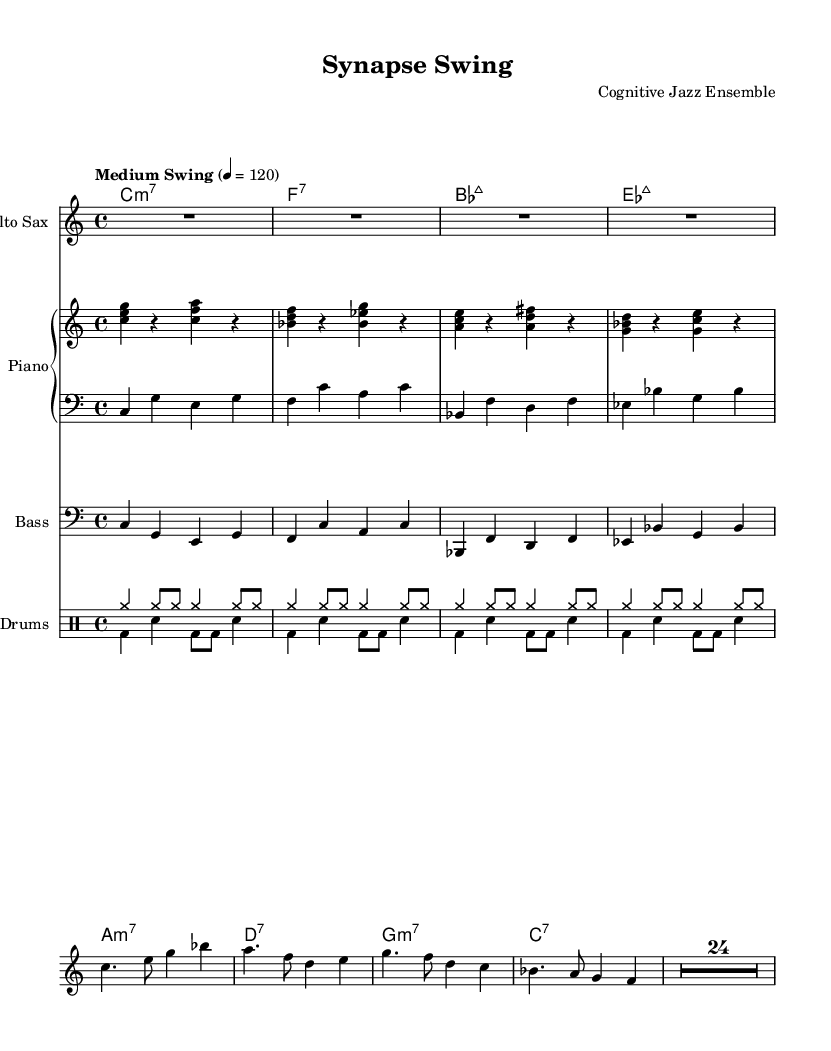What is the key signature of this music? The key signature is C major, which has no sharps or flats.
Answer: C major What is the time signature of this music? The time signature is indicated at the start of the score, showing that there are four beats in each measure.
Answer: 4/4 What is the tempo marking for this piece? The tempo marking specifies that the piece should be played at a medium swing tempo of 120 beats per minute.
Answer: Medium Swing How many measures are in the saxophone part? By counting the lines and the measures within the saxophone section, I can see that there are a total of 8 measures.
Answer: 8 What chord is played in the first measure of the piano right hand? The chord played is a C major chord, which consists of the notes C, E, and G.
Answer: C major In the rhythm section, how do the bass notes relate to the piano left hand? The bass notes are essentially playing the same notes as the piano left hand, reinforcing the harmonic structure of the piece.
Answer: They are the same What type of jazz influence can be identified in the composition? The composition features a swing style, which is characteristic of jazz music, emphasizing syncopated rhythms and a feeling of flow.
Answer: Swing 